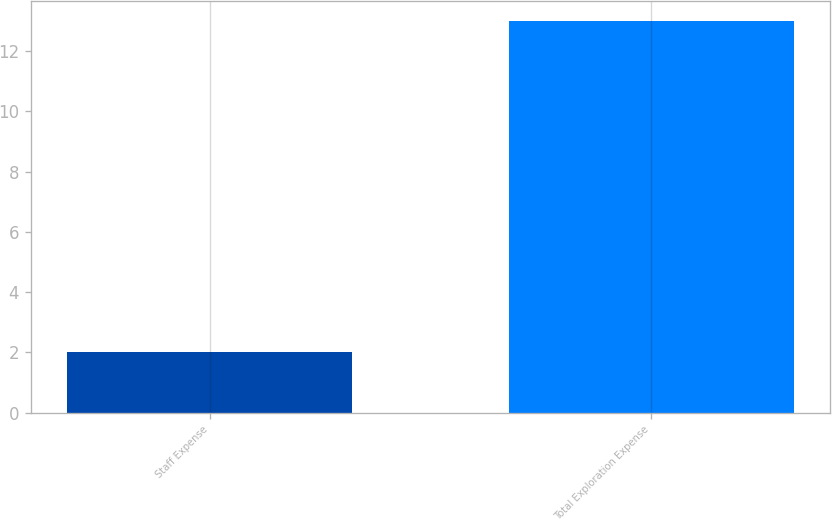Convert chart to OTSL. <chart><loc_0><loc_0><loc_500><loc_500><bar_chart><fcel>Staff Expense<fcel>Total Exploration Expense<nl><fcel>2<fcel>13<nl></chart> 